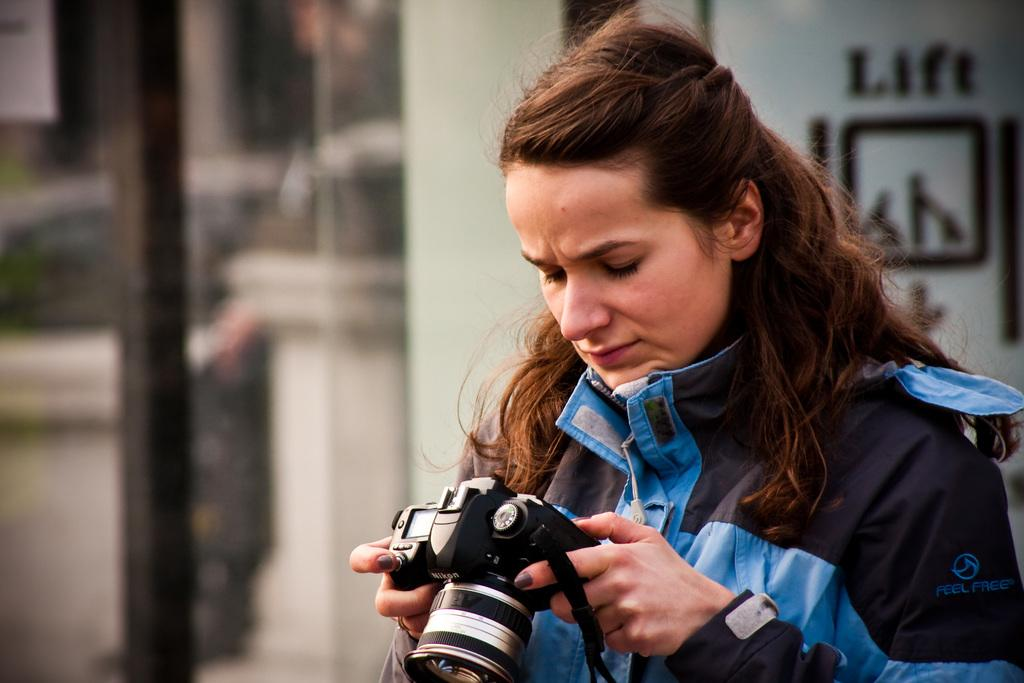Who is the main subject in the image? There is a girl in the image. What is the girl holding in the image? The girl is holding a camera. What type of clothing is the girl wearing in the image? The girl is wearing a coat. What type of discovery did the girl make while holding the twig in the image? There is no twig present in the image, and therefore no such discovery can be observed. 